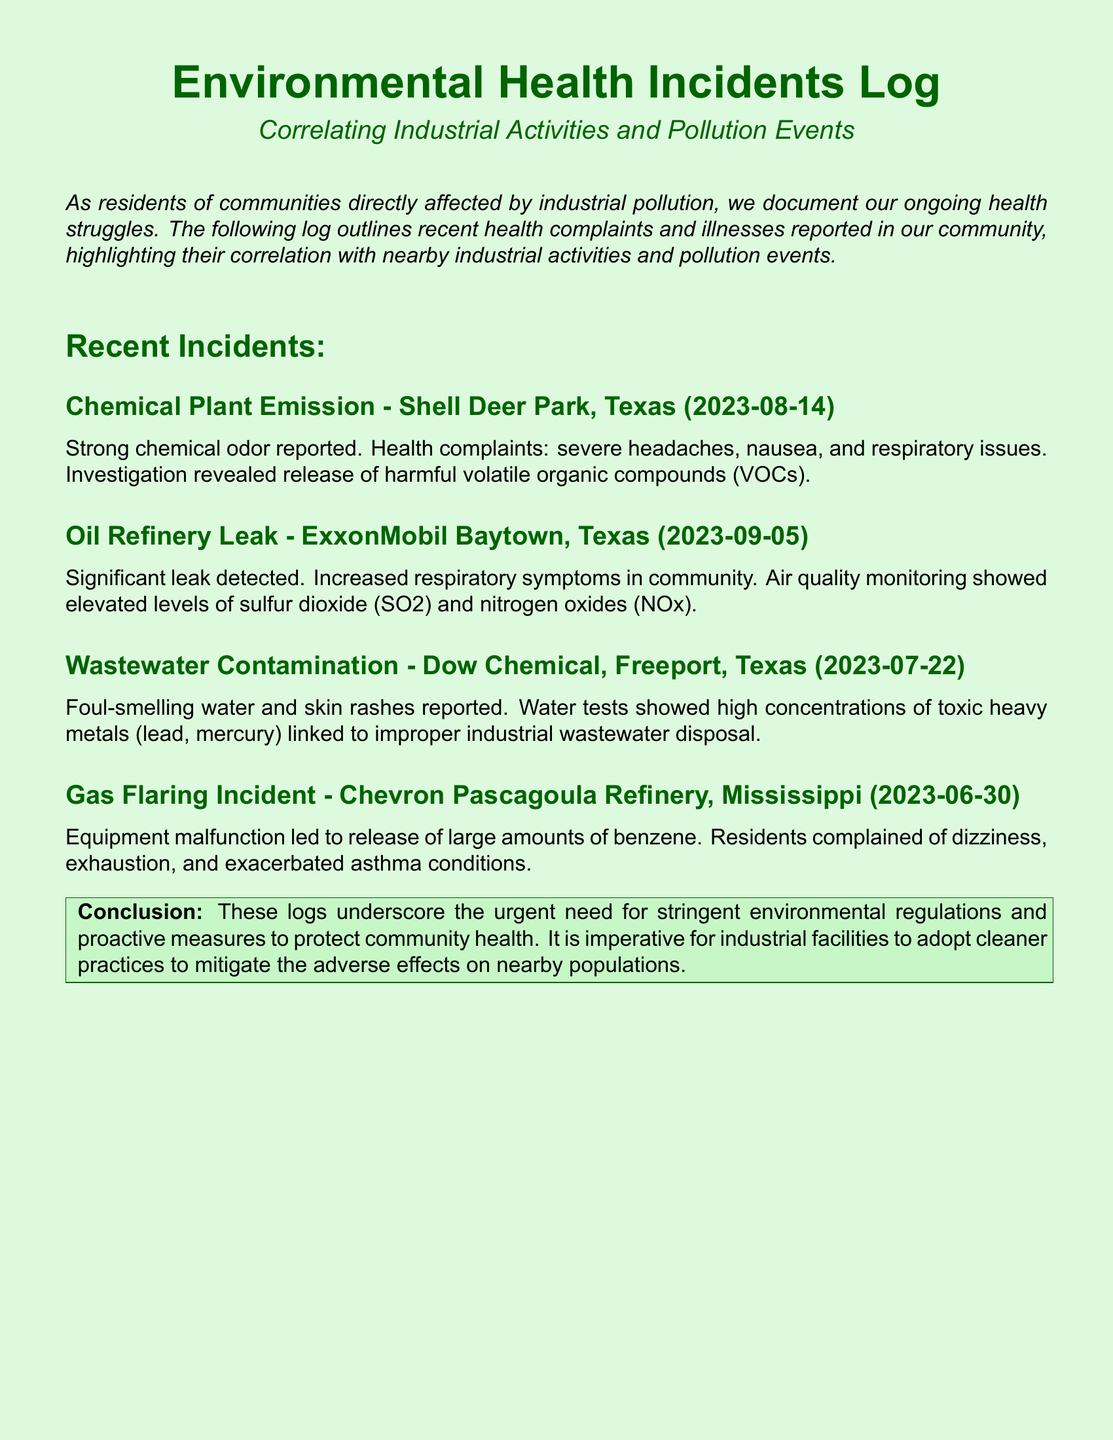What incident occurred on August 14, 2023? The incident on this date was a chemical plant emission at Shell Deer Park, Texas.
Answer: Chemical Plant Emission What health complaints were reported during the ExxonMobil leak? The health complaints included increased respiratory symptoms in the community.
Answer: Increased respiratory symptoms Which toxic metals were identified in the Dow Chemical wastewater contamination? The water tests showed high concentrations of lead and mercury.
Answer: Lead, mercury What caused the gas flaring incident at Chevron Pascagoula Refinery? The gas flaring incident was caused by an equipment malfunction.
Answer: Equipment malfunction What was the main chemical released during the Chevron incident? The main chemical released was benzene.
Answer: Benzene What is the date of the Dow Chemical wastewater contamination incident? The date of the incident was July 22, 2023.
Answer: July 22, 2023 How many recent incidents are listed in the log? There are four recent incidents outlined in the log.
Answer: Four What conclusion is drawn from the incidents documented? The conclusion emphasizes the need for stringent environmental regulations.
Answer: Need for stringent environmental regulations Which industrial facility is associated with the foul-smelling water complaints? The industrial facility associated is Dow Chemical in Freeport, Texas.
Answer: Dow Chemical 